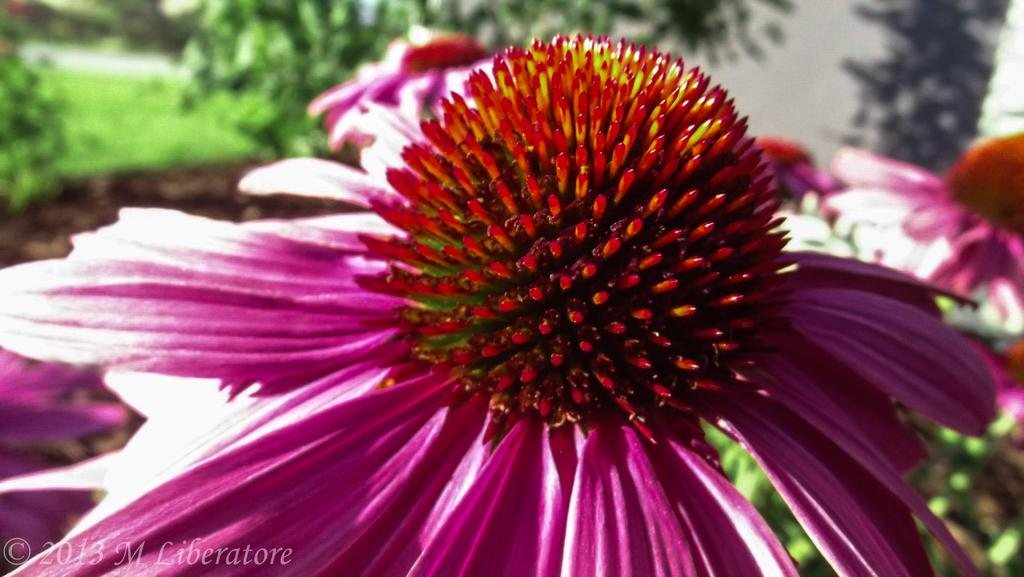What type of plants can be seen in the image? There are flowers in the image. What can be seen in the background of the image? There are trees and grass in the background of the image. Where is the cushion located in the image? There is no cushion present in the image. 